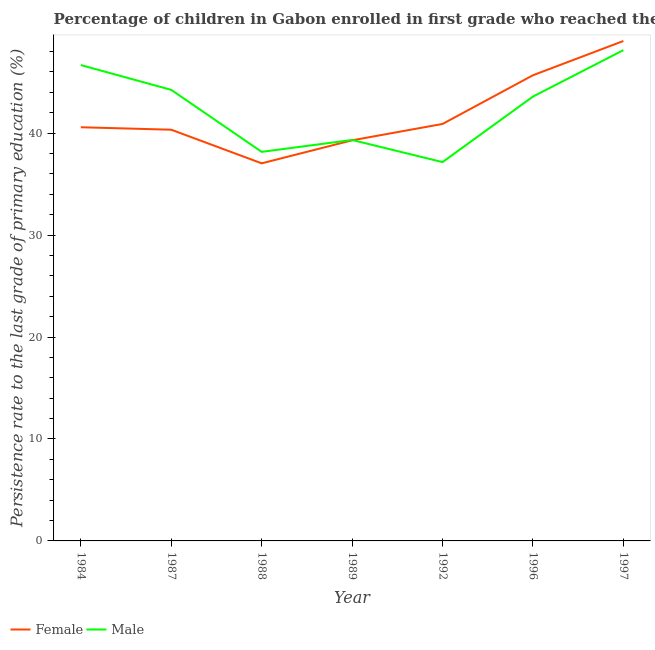Does the line corresponding to persistence rate of male students intersect with the line corresponding to persistence rate of female students?
Your answer should be very brief. Yes. What is the persistence rate of male students in 1992?
Your response must be concise. 37.15. Across all years, what is the maximum persistence rate of male students?
Offer a terse response. 48.14. Across all years, what is the minimum persistence rate of male students?
Offer a terse response. 37.15. In which year was the persistence rate of female students maximum?
Your answer should be very brief. 1997. In which year was the persistence rate of female students minimum?
Provide a short and direct response. 1988. What is the total persistence rate of female students in the graph?
Provide a short and direct response. 292.83. What is the difference between the persistence rate of female students in 1984 and that in 1989?
Provide a succinct answer. 1.28. What is the difference between the persistence rate of female students in 1992 and the persistence rate of male students in 1984?
Offer a very short reply. -5.78. What is the average persistence rate of female students per year?
Offer a very short reply. 41.83. In the year 1984, what is the difference between the persistence rate of female students and persistence rate of male students?
Your response must be concise. -6.1. In how many years, is the persistence rate of male students greater than 26 %?
Make the answer very short. 7. What is the ratio of the persistence rate of male students in 1987 to that in 1988?
Give a very brief answer. 1.16. Is the difference between the persistence rate of male students in 1984 and 1989 greater than the difference between the persistence rate of female students in 1984 and 1989?
Make the answer very short. Yes. What is the difference between the highest and the second highest persistence rate of male students?
Your answer should be compact. 1.46. What is the difference between the highest and the lowest persistence rate of female students?
Offer a very short reply. 12. How many lines are there?
Your response must be concise. 2. How many years are there in the graph?
Give a very brief answer. 7. What is the difference between two consecutive major ticks on the Y-axis?
Provide a succinct answer. 10. Are the values on the major ticks of Y-axis written in scientific E-notation?
Your answer should be compact. No. Does the graph contain any zero values?
Your answer should be very brief. No. Does the graph contain grids?
Ensure brevity in your answer.  No. Where does the legend appear in the graph?
Offer a very short reply. Bottom left. How many legend labels are there?
Make the answer very short. 2. What is the title of the graph?
Keep it short and to the point. Percentage of children in Gabon enrolled in first grade who reached the last grade of primary education. Does "Frequency of shipment arrival" appear as one of the legend labels in the graph?
Provide a short and direct response. No. What is the label or title of the X-axis?
Your response must be concise. Year. What is the label or title of the Y-axis?
Your response must be concise. Persistence rate to the last grade of primary education (%). What is the Persistence rate to the last grade of primary education (%) of Female in 1984?
Offer a terse response. 40.57. What is the Persistence rate to the last grade of primary education (%) in Male in 1984?
Provide a succinct answer. 46.67. What is the Persistence rate to the last grade of primary education (%) of Female in 1987?
Your response must be concise. 40.33. What is the Persistence rate to the last grade of primary education (%) in Male in 1987?
Offer a very short reply. 44.24. What is the Persistence rate to the last grade of primary education (%) in Female in 1988?
Provide a short and direct response. 37.03. What is the Persistence rate to the last grade of primary education (%) of Male in 1988?
Make the answer very short. 38.16. What is the Persistence rate to the last grade of primary education (%) of Female in 1989?
Make the answer very short. 39.29. What is the Persistence rate to the last grade of primary education (%) of Male in 1989?
Offer a very short reply. 39.32. What is the Persistence rate to the last grade of primary education (%) in Female in 1992?
Your answer should be very brief. 40.9. What is the Persistence rate to the last grade of primary education (%) in Male in 1992?
Ensure brevity in your answer.  37.15. What is the Persistence rate to the last grade of primary education (%) of Female in 1996?
Provide a short and direct response. 45.67. What is the Persistence rate to the last grade of primary education (%) in Male in 1996?
Offer a terse response. 43.58. What is the Persistence rate to the last grade of primary education (%) of Female in 1997?
Your answer should be compact. 49.03. What is the Persistence rate to the last grade of primary education (%) in Male in 1997?
Give a very brief answer. 48.14. Across all years, what is the maximum Persistence rate to the last grade of primary education (%) of Female?
Your answer should be very brief. 49.03. Across all years, what is the maximum Persistence rate to the last grade of primary education (%) in Male?
Offer a very short reply. 48.14. Across all years, what is the minimum Persistence rate to the last grade of primary education (%) of Female?
Your answer should be compact. 37.03. Across all years, what is the minimum Persistence rate to the last grade of primary education (%) of Male?
Your answer should be compact. 37.15. What is the total Persistence rate to the last grade of primary education (%) in Female in the graph?
Make the answer very short. 292.82. What is the total Persistence rate to the last grade of primary education (%) of Male in the graph?
Your response must be concise. 297.26. What is the difference between the Persistence rate to the last grade of primary education (%) of Female in 1984 and that in 1987?
Your response must be concise. 0.24. What is the difference between the Persistence rate to the last grade of primary education (%) of Male in 1984 and that in 1987?
Provide a short and direct response. 2.43. What is the difference between the Persistence rate to the last grade of primary education (%) of Female in 1984 and that in 1988?
Offer a terse response. 3.54. What is the difference between the Persistence rate to the last grade of primary education (%) in Male in 1984 and that in 1988?
Provide a short and direct response. 8.51. What is the difference between the Persistence rate to the last grade of primary education (%) in Female in 1984 and that in 1989?
Make the answer very short. 1.28. What is the difference between the Persistence rate to the last grade of primary education (%) in Male in 1984 and that in 1989?
Give a very brief answer. 7.35. What is the difference between the Persistence rate to the last grade of primary education (%) of Female in 1984 and that in 1992?
Your response must be concise. -0.32. What is the difference between the Persistence rate to the last grade of primary education (%) in Male in 1984 and that in 1992?
Your response must be concise. 9.52. What is the difference between the Persistence rate to the last grade of primary education (%) in Female in 1984 and that in 1996?
Your response must be concise. -5.1. What is the difference between the Persistence rate to the last grade of primary education (%) of Male in 1984 and that in 1996?
Your response must be concise. 3.09. What is the difference between the Persistence rate to the last grade of primary education (%) in Female in 1984 and that in 1997?
Your answer should be compact. -8.46. What is the difference between the Persistence rate to the last grade of primary education (%) of Male in 1984 and that in 1997?
Your answer should be very brief. -1.46. What is the difference between the Persistence rate to the last grade of primary education (%) in Female in 1987 and that in 1988?
Make the answer very short. 3.3. What is the difference between the Persistence rate to the last grade of primary education (%) of Male in 1987 and that in 1988?
Make the answer very short. 6.08. What is the difference between the Persistence rate to the last grade of primary education (%) of Female in 1987 and that in 1989?
Keep it short and to the point. 1.04. What is the difference between the Persistence rate to the last grade of primary education (%) in Male in 1987 and that in 1989?
Offer a terse response. 4.91. What is the difference between the Persistence rate to the last grade of primary education (%) of Female in 1987 and that in 1992?
Your answer should be compact. -0.57. What is the difference between the Persistence rate to the last grade of primary education (%) of Male in 1987 and that in 1992?
Offer a terse response. 7.09. What is the difference between the Persistence rate to the last grade of primary education (%) in Female in 1987 and that in 1996?
Make the answer very short. -5.34. What is the difference between the Persistence rate to the last grade of primary education (%) in Male in 1987 and that in 1996?
Your answer should be compact. 0.66. What is the difference between the Persistence rate to the last grade of primary education (%) in Female in 1987 and that in 1997?
Offer a terse response. -8.7. What is the difference between the Persistence rate to the last grade of primary education (%) in Male in 1987 and that in 1997?
Provide a succinct answer. -3.9. What is the difference between the Persistence rate to the last grade of primary education (%) of Female in 1988 and that in 1989?
Provide a short and direct response. -2.26. What is the difference between the Persistence rate to the last grade of primary education (%) in Male in 1988 and that in 1989?
Your answer should be very brief. -1.17. What is the difference between the Persistence rate to the last grade of primary education (%) in Female in 1988 and that in 1992?
Provide a succinct answer. -3.86. What is the difference between the Persistence rate to the last grade of primary education (%) in Female in 1988 and that in 1996?
Your response must be concise. -8.64. What is the difference between the Persistence rate to the last grade of primary education (%) in Male in 1988 and that in 1996?
Offer a terse response. -5.42. What is the difference between the Persistence rate to the last grade of primary education (%) of Female in 1988 and that in 1997?
Make the answer very short. -12. What is the difference between the Persistence rate to the last grade of primary education (%) in Male in 1988 and that in 1997?
Offer a very short reply. -9.98. What is the difference between the Persistence rate to the last grade of primary education (%) of Female in 1989 and that in 1992?
Provide a short and direct response. -1.6. What is the difference between the Persistence rate to the last grade of primary education (%) of Male in 1989 and that in 1992?
Provide a short and direct response. 2.17. What is the difference between the Persistence rate to the last grade of primary education (%) of Female in 1989 and that in 1996?
Offer a very short reply. -6.38. What is the difference between the Persistence rate to the last grade of primary education (%) of Male in 1989 and that in 1996?
Your answer should be very brief. -4.26. What is the difference between the Persistence rate to the last grade of primary education (%) of Female in 1989 and that in 1997?
Offer a terse response. -9.74. What is the difference between the Persistence rate to the last grade of primary education (%) in Male in 1989 and that in 1997?
Keep it short and to the point. -8.81. What is the difference between the Persistence rate to the last grade of primary education (%) of Female in 1992 and that in 1996?
Offer a very short reply. -4.78. What is the difference between the Persistence rate to the last grade of primary education (%) in Male in 1992 and that in 1996?
Provide a short and direct response. -6.43. What is the difference between the Persistence rate to the last grade of primary education (%) of Female in 1992 and that in 1997?
Keep it short and to the point. -8.14. What is the difference between the Persistence rate to the last grade of primary education (%) of Male in 1992 and that in 1997?
Your answer should be very brief. -10.98. What is the difference between the Persistence rate to the last grade of primary education (%) in Female in 1996 and that in 1997?
Your answer should be very brief. -3.36. What is the difference between the Persistence rate to the last grade of primary education (%) of Male in 1996 and that in 1997?
Give a very brief answer. -4.56. What is the difference between the Persistence rate to the last grade of primary education (%) of Female in 1984 and the Persistence rate to the last grade of primary education (%) of Male in 1987?
Offer a terse response. -3.67. What is the difference between the Persistence rate to the last grade of primary education (%) of Female in 1984 and the Persistence rate to the last grade of primary education (%) of Male in 1988?
Make the answer very short. 2.41. What is the difference between the Persistence rate to the last grade of primary education (%) of Female in 1984 and the Persistence rate to the last grade of primary education (%) of Male in 1989?
Provide a succinct answer. 1.25. What is the difference between the Persistence rate to the last grade of primary education (%) in Female in 1984 and the Persistence rate to the last grade of primary education (%) in Male in 1992?
Your answer should be very brief. 3.42. What is the difference between the Persistence rate to the last grade of primary education (%) in Female in 1984 and the Persistence rate to the last grade of primary education (%) in Male in 1996?
Your response must be concise. -3.01. What is the difference between the Persistence rate to the last grade of primary education (%) of Female in 1984 and the Persistence rate to the last grade of primary education (%) of Male in 1997?
Offer a very short reply. -7.56. What is the difference between the Persistence rate to the last grade of primary education (%) in Female in 1987 and the Persistence rate to the last grade of primary education (%) in Male in 1988?
Your response must be concise. 2.17. What is the difference between the Persistence rate to the last grade of primary education (%) in Female in 1987 and the Persistence rate to the last grade of primary education (%) in Male in 1989?
Your answer should be very brief. 1.01. What is the difference between the Persistence rate to the last grade of primary education (%) of Female in 1987 and the Persistence rate to the last grade of primary education (%) of Male in 1992?
Your answer should be compact. 3.18. What is the difference between the Persistence rate to the last grade of primary education (%) in Female in 1987 and the Persistence rate to the last grade of primary education (%) in Male in 1996?
Provide a succinct answer. -3.25. What is the difference between the Persistence rate to the last grade of primary education (%) in Female in 1987 and the Persistence rate to the last grade of primary education (%) in Male in 1997?
Your answer should be compact. -7.81. What is the difference between the Persistence rate to the last grade of primary education (%) of Female in 1988 and the Persistence rate to the last grade of primary education (%) of Male in 1989?
Offer a terse response. -2.29. What is the difference between the Persistence rate to the last grade of primary education (%) in Female in 1988 and the Persistence rate to the last grade of primary education (%) in Male in 1992?
Your answer should be compact. -0.12. What is the difference between the Persistence rate to the last grade of primary education (%) in Female in 1988 and the Persistence rate to the last grade of primary education (%) in Male in 1996?
Offer a terse response. -6.55. What is the difference between the Persistence rate to the last grade of primary education (%) of Female in 1988 and the Persistence rate to the last grade of primary education (%) of Male in 1997?
Provide a succinct answer. -11.1. What is the difference between the Persistence rate to the last grade of primary education (%) in Female in 1989 and the Persistence rate to the last grade of primary education (%) in Male in 1992?
Provide a succinct answer. 2.14. What is the difference between the Persistence rate to the last grade of primary education (%) in Female in 1989 and the Persistence rate to the last grade of primary education (%) in Male in 1996?
Give a very brief answer. -4.29. What is the difference between the Persistence rate to the last grade of primary education (%) of Female in 1989 and the Persistence rate to the last grade of primary education (%) of Male in 1997?
Your answer should be compact. -8.85. What is the difference between the Persistence rate to the last grade of primary education (%) in Female in 1992 and the Persistence rate to the last grade of primary education (%) in Male in 1996?
Make the answer very short. -2.68. What is the difference between the Persistence rate to the last grade of primary education (%) in Female in 1992 and the Persistence rate to the last grade of primary education (%) in Male in 1997?
Provide a succinct answer. -7.24. What is the difference between the Persistence rate to the last grade of primary education (%) in Female in 1996 and the Persistence rate to the last grade of primary education (%) in Male in 1997?
Your response must be concise. -2.46. What is the average Persistence rate to the last grade of primary education (%) of Female per year?
Provide a short and direct response. 41.83. What is the average Persistence rate to the last grade of primary education (%) of Male per year?
Offer a very short reply. 42.47. In the year 1984, what is the difference between the Persistence rate to the last grade of primary education (%) in Female and Persistence rate to the last grade of primary education (%) in Male?
Give a very brief answer. -6.1. In the year 1987, what is the difference between the Persistence rate to the last grade of primary education (%) of Female and Persistence rate to the last grade of primary education (%) of Male?
Offer a very short reply. -3.91. In the year 1988, what is the difference between the Persistence rate to the last grade of primary education (%) in Female and Persistence rate to the last grade of primary education (%) in Male?
Provide a short and direct response. -1.12. In the year 1989, what is the difference between the Persistence rate to the last grade of primary education (%) of Female and Persistence rate to the last grade of primary education (%) of Male?
Provide a succinct answer. -0.03. In the year 1992, what is the difference between the Persistence rate to the last grade of primary education (%) in Female and Persistence rate to the last grade of primary education (%) in Male?
Keep it short and to the point. 3.74. In the year 1996, what is the difference between the Persistence rate to the last grade of primary education (%) in Female and Persistence rate to the last grade of primary education (%) in Male?
Your answer should be compact. 2.09. In the year 1997, what is the difference between the Persistence rate to the last grade of primary education (%) of Female and Persistence rate to the last grade of primary education (%) of Male?
Offer a very short reply. 0.9. What is the ratio of the Persistence rate to the last grade of primary education (%) in Male in 1984 to that in 1987?
Provide a succinct answer. 1.05. What is the ratio of the Persistence rate to the last grade of primary education (%) of Female in 1984 to that in 1988?
Provide a short and direct response. 1.1. What is the ratio of the Persistence rate to the last grade of primary education (%) in Male in 1984 to that in 1988?
Your response must be concise. 1.22. What is the ratio of the Persistence rate to the last grade of primary education (%) of Female in 1984 to that in 1989?
Your response must be concise. 1.03. What is the ratio of the Persistence rate to the last grade of primary education (%) in Male in 1984 to that in 1989?
Your response must be concise. 1.19. What is the ratio of the Persistence rate to the last grade of primary education (%) in Male in 1984 to that in 1992?
Make the answer very short. 1.26. What is the ratio of the Persistence rate to the last grade of primary education (%) of Female in 1984 to that in 1996?
Offer a terse response. 0.89. What is the ratio of the Persistence rate to the last grade of primary education (%) in Male in 1984 to that in 1996?
Offer a terse response. 1.07. What is the ratio of the Persistence rate to the last grade of primary education (%) in Female in 1984 to that in 1997?
Your answer should be very brief. 0.83. What is the ratio of the Persistence rate to the last grade of primary education (%) in Male in 1984 to that in 1997?
Your answer should be compact. 0.97. What is the ratio of the Persistence rate to the last grade of primary education (%) of Female in 1987 to that in 1988?
Provide a succinct answer. 1.09. What is the ratio of the Persistence rate to the last grade of primary education (%) of Male in 1987 to that in 1988?
Give a very brief answer. 1.16. What is the ratio of the Persistence rate to the last grade of primary education (%) of Female in 1987 to that in 1989?
Offer a terse response. 1.03. What is the ratio of the Persistence rate to the last grade of primary education (%) of Female in 1987 to that in 1992?
Your answer should be compact. 0.99. What is the ratio of the Persistence rate to the last grade of primary education (%) of Male in 1987 to that in 1992?
Make the answer very short. 1.19. What is the ratio of the Persistence rate to the last grade of primary education (%) of Female in 1987 to that in 1996?
Your answer should be very brief. 0.88. What is the ratio of the Persistence rate to the last grade of primary education (%) in Male in 1987 to that in 1996?
Provide a succinct answer. 1.02. What is the ratio of the Persistence rate to the last grade of primary education (%) in Female in 1987 to that in 1997?
Give a very brief answer. 0.82. What is the ratio of the Persistence rate to the last grade of primary education (%) in Male in 1987 to that in 1997?
Give a very brief answer. 0.92. What is the ratio of the Persistence rate to the last grade of primary education (%) of Female in 1988 to that in 1989?
Your response must be concise. 0.94. What is the ratio of the Persistence rate to the last grade of primary education (%) in Male in 1988 to that in 1989?
Make the answer very short. 0.97. What is the ratio of the Persistence rate to the last grade of primary education (%) of Female in 1988 to that in 1992?
Your answer should be very brief. 0.91. What is the ratio of the Persistence rate to the last grade of primary education (%) of Male in 1988 to that in 1992?
Your response must be concise. 1.03. What is the ratio of the Persistence rate to the last grade of primary education (%) in Female in 1988 to that in 1996?
Provide a short and direct response. 0.81. What is the ratio of the Persistence rate to the last grade of primary education (%) of Male in 1988 to that in 1996?
Keep it short and to the point. 0.88. What is the ratio of the Persistence rate to the last grade of primary education (%) of Female in 1988 to that in 1997?
Your answer should be compact. 0.76. What is the ratio of the Persistence rate to the last grade of primary education (%) of Male in 1988 to that in 1997?
Ensure brevity in your answer.  0.79. What is the ratio of the Persistence rate to the last grade of primary education (%) of Female in 1989 to that in 1992?
Ensure brevity in your answer.  0.96. What is the ratio of the Persistence rate to the last grade of primary education (%) in Male in 1989 to that in 1992?
Offer a terse response. 1.06. What is the ratio of the Persistence rate to the last grade of primary education (%) of Female in 1989 to that in 1996?
Offer a very short reply. 0.86. What is the ratio of the Persistence rate to the last grade of primary education (%) of Male in 1989 to that in 1996?
Offer a very short reply. 0.9. What is the ratio of the Persistence rate to the last grade of primary education (%) in Female in 1989 to that in 1997?
Your answer should be compact. 0.8. What is the ratio of the Persistence rate to the last grade of primary education (%) of Male in 1989 to that in 1997?
Your answer should be very brief. 0.82. What is the ratio of the Persistence rate to the last grade of primary education (%) of Female in 1992 to that in 1996?
Your answer should be compact. 0.9. What is the ratio of the Persistence rate to the last grade of primary education (%) in Male in 1992 to that in 1996?
Provide a short and direct response. 0.85. What is the ratio of the Persistence rate to the last grade of primary education (%) in Female in 1992 to that in 1997?
Your response must be concise. 0.83. What is the ratio of the Persistence rate to the last grade of primary education (%) of Male in 1992 to that in 1997?
Keep it short and to the point. 0.77. What is the ratio of the Persistence rate to the last grade of primary education (%) in Female in 1996 to that in 1997?
Your answer should be compact. 0.93. What is the ratio of the Persistence rate to the last grade of primary education (%) in Male in 1996 to that in 1997?
Your answer should be very brief. 0.91. What is the difference between the highest and the second highest Persistence rate to the last grade of primary education (%) of Female?
Make the answer very short. 3.36. What is the difference between the highest and the second highest Persistence rate to the last grade of primary education (%) in Male?
Provide a short and direct response. 1.46. What is the difference between the highest and the lowest Persistence rate to the last grade of primary education (%) of Female?
Provide a succinct answer. 12. What is the difference between the highest and the lowest Persistence rate to the last grade of primary education (%) of Male?
Make the answer very short. 10.98. 